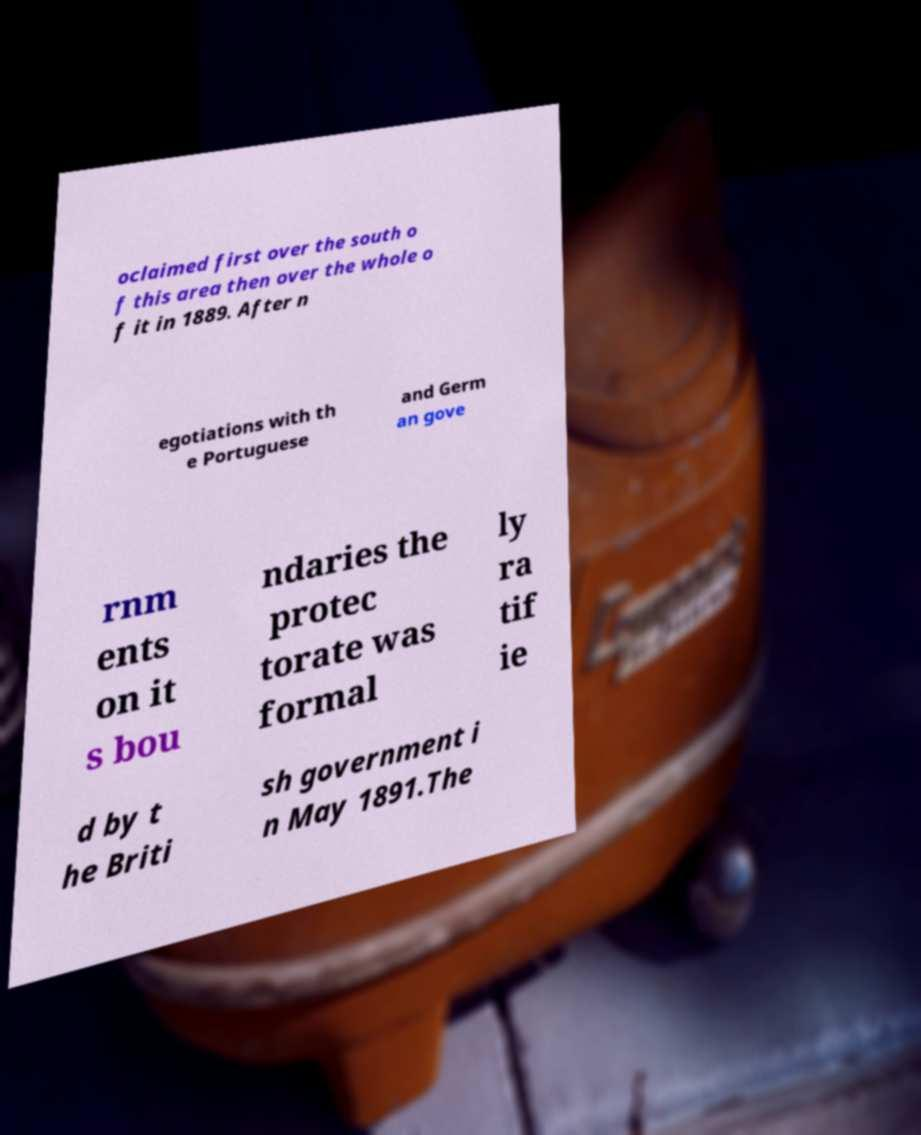For documentation purposes, I need the text within this image transcribed. Could you provide that? oclaimed first over the south o f this area then over the whole o f it in 1889. After n egotiations with th e Portuguese and Germ an gove rnm ents on it s bou ndaries the protec torate was formal ly ra tif ie d by t he Briti sh government i n May 1891.The 